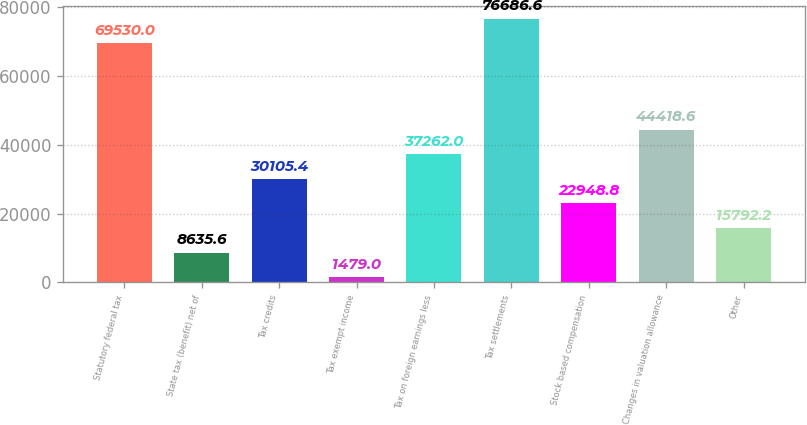Convert chart to OTSL. <chart><loc_0><loc_0><loc_500><loc_500><bar_chart><fcel>Statutory federal tax<fcel>State tax (benefit) net of<fcel>Tax credits<fcel>Tax exempt income<fcel>Tax on foreign earnings less<fcel>Tax settlements<fcel>Stock based compensation<fcel>Changes in valuation allowance<fcel>Other<nl><fcel>69530<fcel>8635.6<fcel>30105.4<fcel>1479<fcel>37262<fcel>76686.6<fcel>22948.8<fcel>44418.6<fcel>15792.2<nl></chart> 